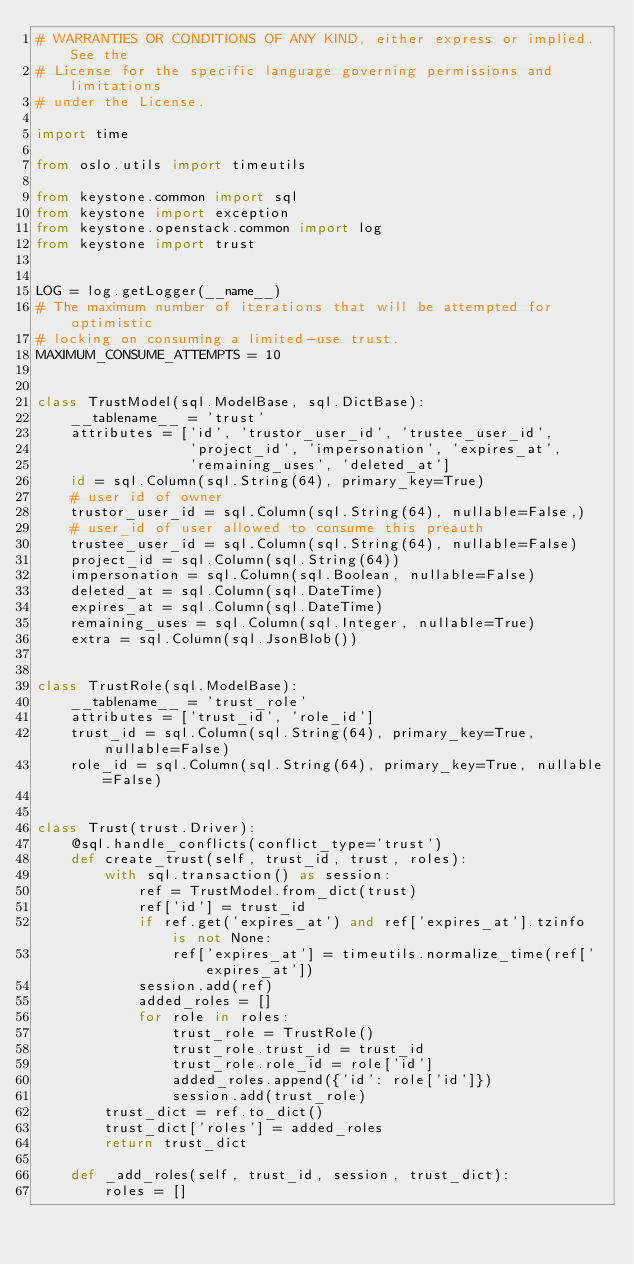Convert code to text. <code><loc_0><loc_0><loc_500><loc_500><_Python_># WARRANTIES OR CONDITIONS OF ANY KIND, either express or implied. See the
# License for the specific language governing permissions and limitations
# under the License.

import time

from oslo.utils import timeutils

from keystone.common import sql
from keystone import exception
from keystone.openstack.common import log
from keystone import trust


LOG = log.getLogger(__name__)
# The maximum number of iterations that will be attempted for optimistic
# locking on consuming a limited-use trust.
MAXIMUM_CONSUME_ATTEMPTS = 10


class TrustModel(sql.ModelBase, sql.DictBase):
    __tablename__ = 'trust'
    attributes = ['id', 'trustor_user_id', 'trustee_user_id',
                  'project_id', 'impersonation', 'expires_at',
                  'remaining_uses', 'deleted_at']
    id = sql.Column(sql.String(64), primary_key=True)
    # user id of owner
    trustor_user_id = sql.Column(sql.String(64), nullable=False,)
    # user_id of user allowed to consume this preauth
    trustee_user_id = sql.Column(sql.String(64), nullable=False)
    project_id = sql.Column(sql.String(64))
    impersonation = sql.Column(sql.Boolean, nullable=False)
    deleted_at = sql.Column(sql.DateTime)
    expires_at = sql.Column(sql.DateTime)
    remaining_uses = sql.Column(sql.Integer, nullable=True)
    extra = sql.Column(sql.JsonBlob())


class TrustRole(sql.ModelBase):
    __tablename__ = 'trust_role'
    attributes = ['trust_id', 'role_id']
    trust_id = sql.Column(sql.String(64), primary_key=True, nullable=False)
    role_id = sql.Column(sql.String(64), primary_key=True, nullable=False)


class Trust(trust.Driver):
    @sql.handle_conflicts(conflict_type='trust')
    def create_trust(self, trust_id, trust, roles):
        with sql.transaction() as session:
            ref = TrustModel.from_dict(trust)
            ref['id'] = trust_id
            if ref.get('expires_at') and ref['expires_at'].tzinfo is not None:
                ref['expires_at'] = timeutils.normalize_time(ref['expires_at'])
            session.add(ref)
            added_roles = []
            for role in roles:
                trust_role = TrustRole()
                trust_role.trust_id = trust_id
                trust_role.role_id = role['id']
                added_roles.append({'id': role['id']})
                session.add(trust_role)
        trust_dict = ref.to_dict()
        trust_dict['roles'] = added_roles
        return trust_dict

    def _add_roles(self, trust_id, session, trust_dict):
        roles = []</code> 